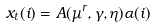Convert formula to latex. <formula><loc_0><loc_0><loc_500><loc_500>x _ { t } ( i ) = A ( \mu ^ { r } , \gamma , \eta ) \alpha ( i )</formula> 